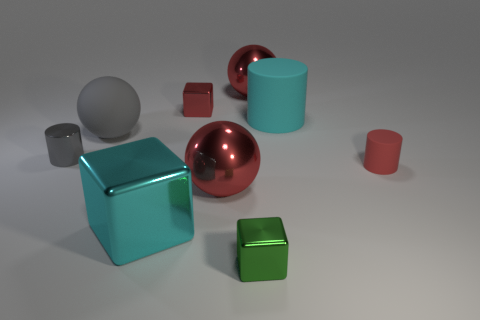Subtract all blocks. How many objects are left? 6 Add 5 matte cylinders. How many matte cylinders exist? 7 Subtract 1 red cubes. How many objects are left? 8 Subtract all large cyan metal objects. Subtract all metal spheres. How many objects are left? 6 Add 2 small red cylinders. How many small red cylinders are left? 3 